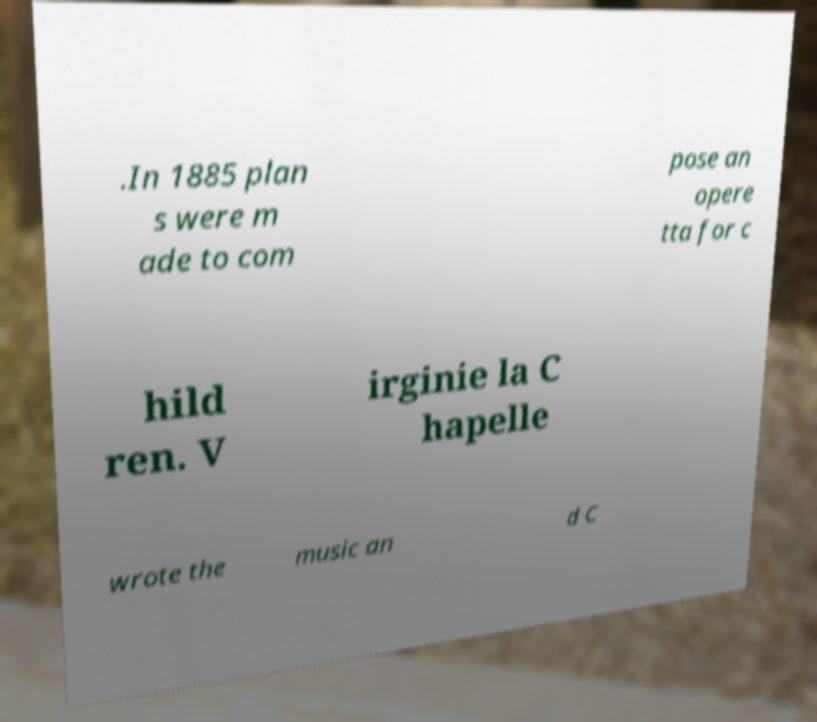For documentation purposes, I need the text within this image transcribed. Could you provide that? .In 1885 plan s were m ade to com pose an opere tta for c hild ren. V irginie la C hapelle wrote the music an d C 